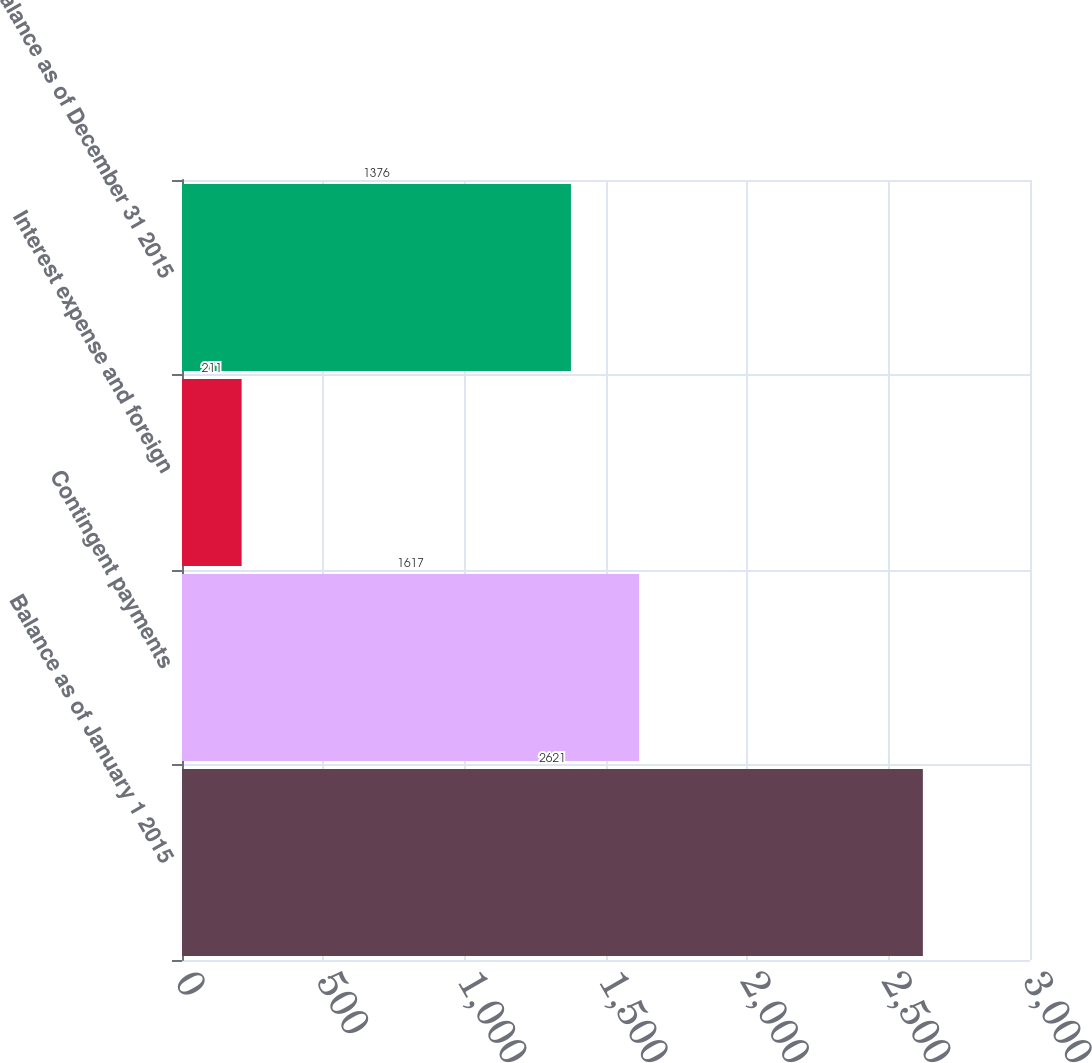<chart> <loc_0><loc_0><loc_500><loc_500><bar_chart><fcel>Balance as of January 1 2015<fcel>Contingent payments<fcel>Interest expense and foreign<fcel>Balance as of December 31 2015<nl><fcel>2621<fcel>1617<fcel>211<fcel>1376<nl></chart> 